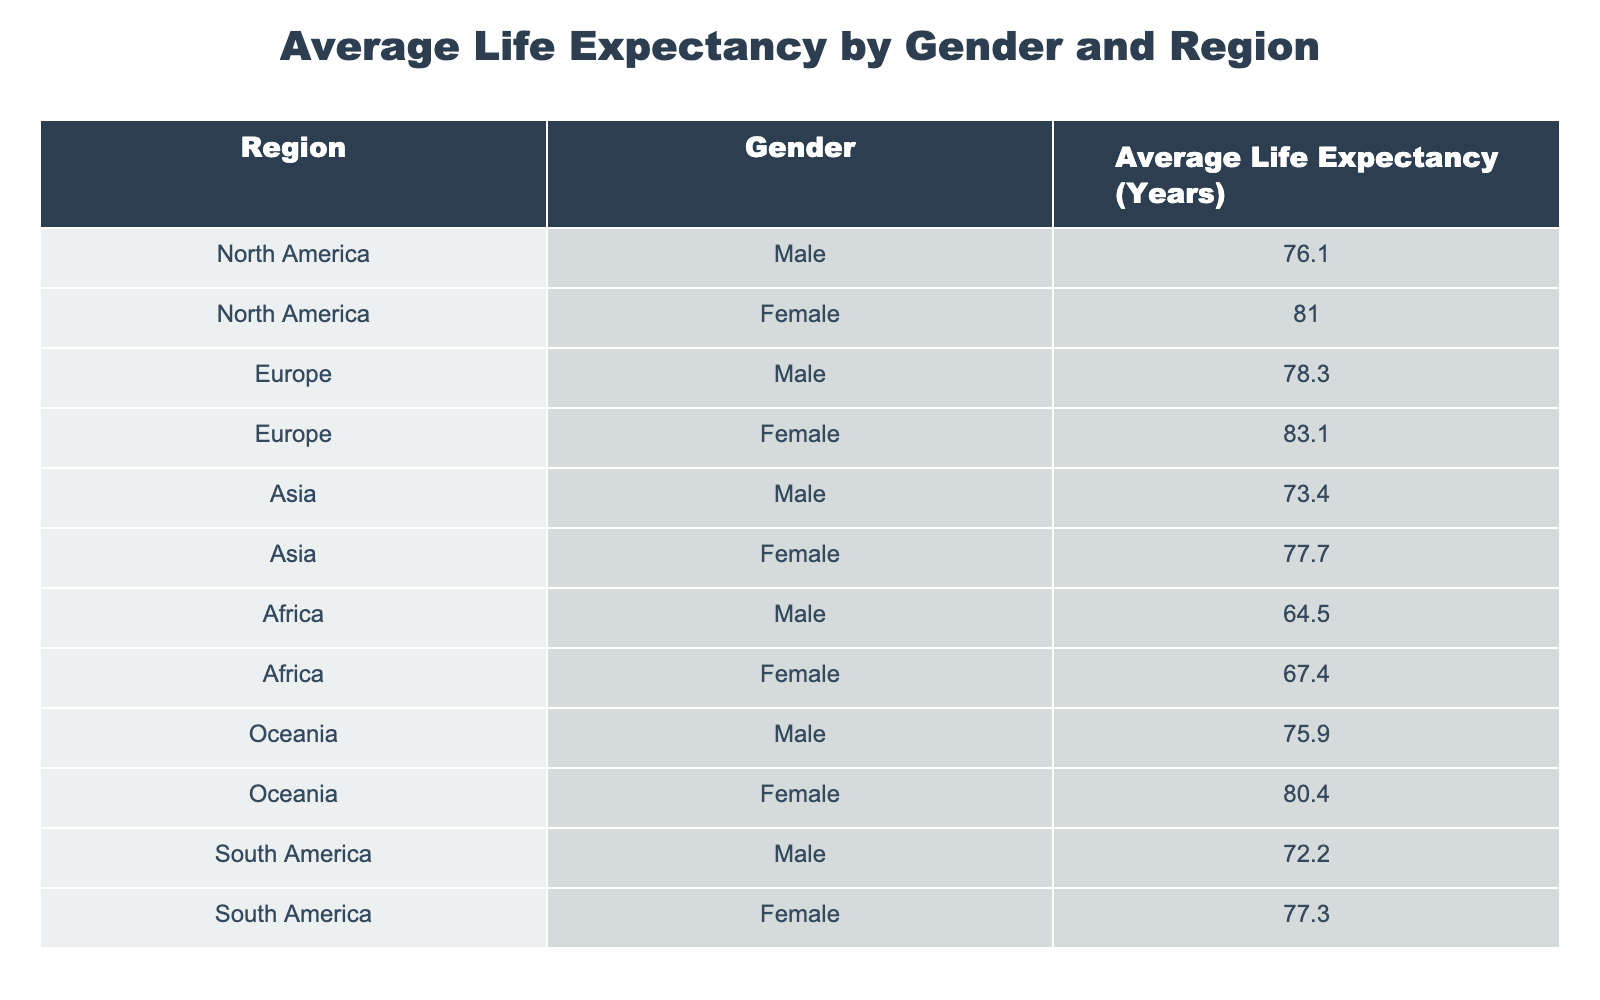What is the average life expectancy for females in Europe? The table shows that the average life expectancy for females in Europe is listed as 83.1 years.
Answer: 83.1 years Which region has the lowest average life expectancy for males? By examining the table, Africa has the lowest average life expectancy for males at 64.5 years.
Answer: Africa What is the difference in average life expectancy between males and females in South America? For South America, males have an average life expectancy of 72.2 years, and females have 77.3 years. The difference is 77.3 - 72.2 = 5.1 years.
Answer: 5.1 years True or False: The average life expectancy for females in Oceania is higher than that for males in Europe. In Oceania, females have an average life expectancy of 80.4 years, while males in Europe have an average of 78.3 years. Since 80.4 is greater than 78.3, the statement is true.
Answer: True What is the average life expectancy for males across all regions combined? To find the average life expectancy for males across all regions, sum the male life expectancies: 76.1 (North America) + 78.3 (Europe) + 73.4 (Asia) + 64.5 (Africa) + 75.9 (Oceania) + 72.2 (South America) = 440.4. There are 6 regions, so the average is 440.4 / 6 = 73.4 years.
Answer: 73.4 years 